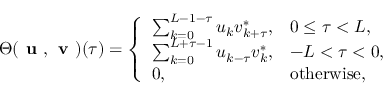Convert formula to latex. <formula><loc_0><loc_0><loc_500><loc_500>\Theta ( u , v ) ( { \tau } ) = \left \{ \begin{array} { l l } { \sum _ { k = 0 } ^ { L - 1 - \tau } u _ { k } v _ { k + \tau } ^ { * } , } & { 0 \leq \tau < L , } \\ { \sum _ { k = 0 } ^ { L + \tau - 1 } u _ { k - \tau } v _ { k } ^ { * } , } & { - L < \tau < 0 , } \\ { 0 , } & { o t h e r w i s e , } \end{array}</formula> 